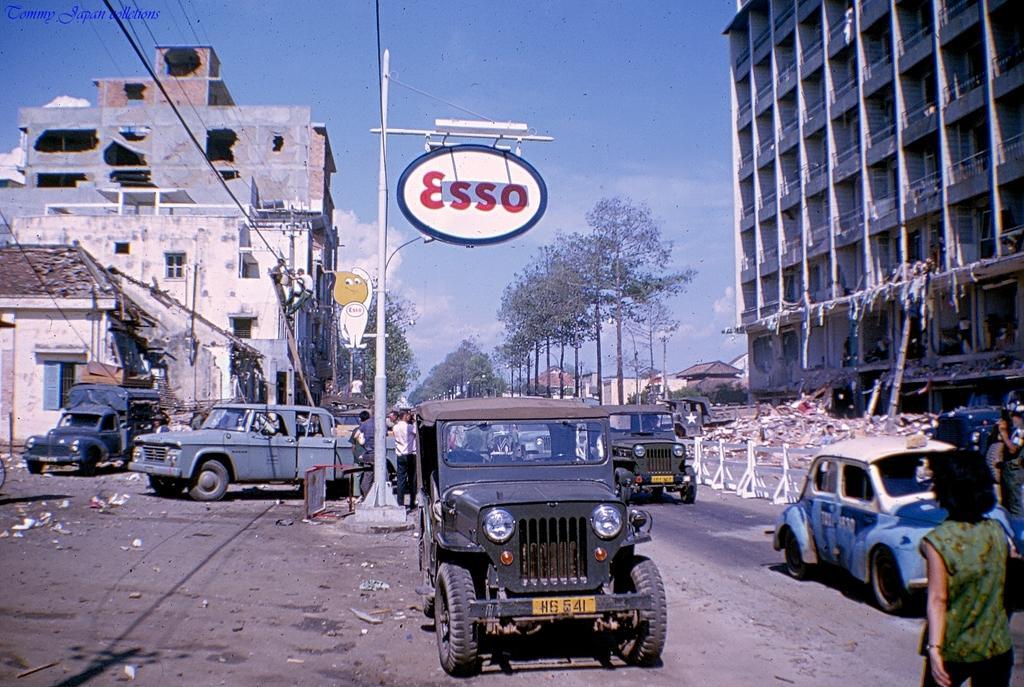Please provide a concise description of this image. In this image we can see these vehicles are on the road, we can see a few people are walking on the road, boards to the poles, wires, trees, buildings and the blue sky with clouds in the background. Here we can see the watermark on the top left side of the image. 